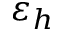Convert formula to latex. <formula><loc_0><loc_0><loc_500><loc_500>\varepsilon _ { h }</formula> 